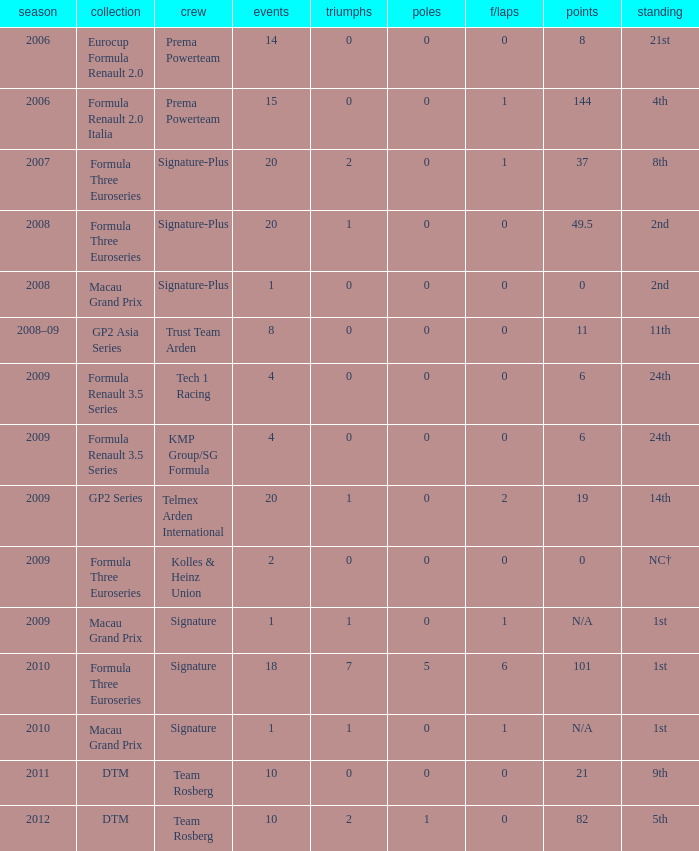Which series has 11 points? GP2 Asia Series. 